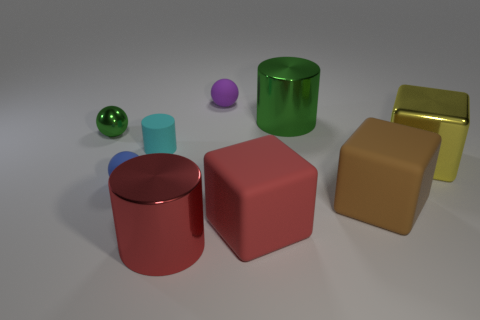Add 1 large metal blocks. How many objects exist? 10 Subtract all cubes. How many objects are left? 6 Add 4 large red rubber things. How many large red rubber things exist? 5 Subtract 1 blue balls. How many objects are left? 8 Subtract all tiny green metal things. Subtract all large brown metal spheres. How many objects are left? 8 Add 6 tiny matte spheres. How many tiny matte spheres are left? 8 